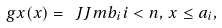Convert formula to latex. <formula><loc_0><loc_0><loc_500><loc_500>\ g x ( x ) = \ J J m { b _ { i } } { i < n , \, x \leq a _ { i } } ,</formula> 